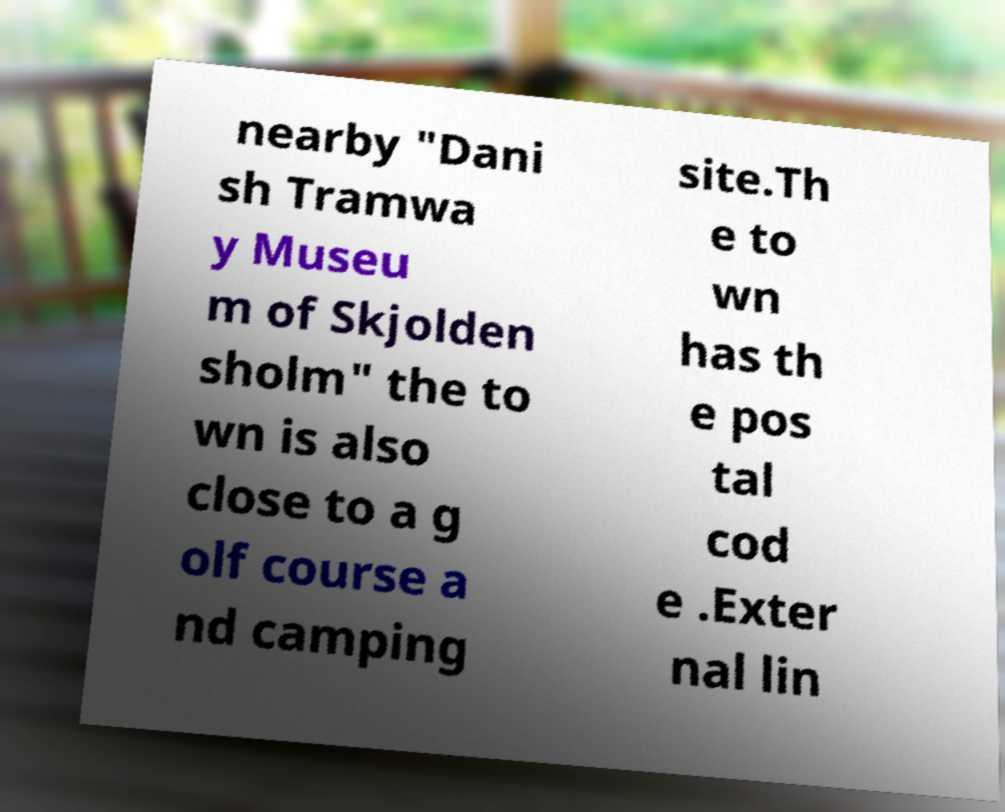Please read and relay the text visible in this image. What does it say? nearby "Dani sh Tramwa y Museu m of Skjolden sholm" the to wn is also close to a g olf course a nd camping site.Th e to wn has th e pos tal cod e .Exter nal lin 